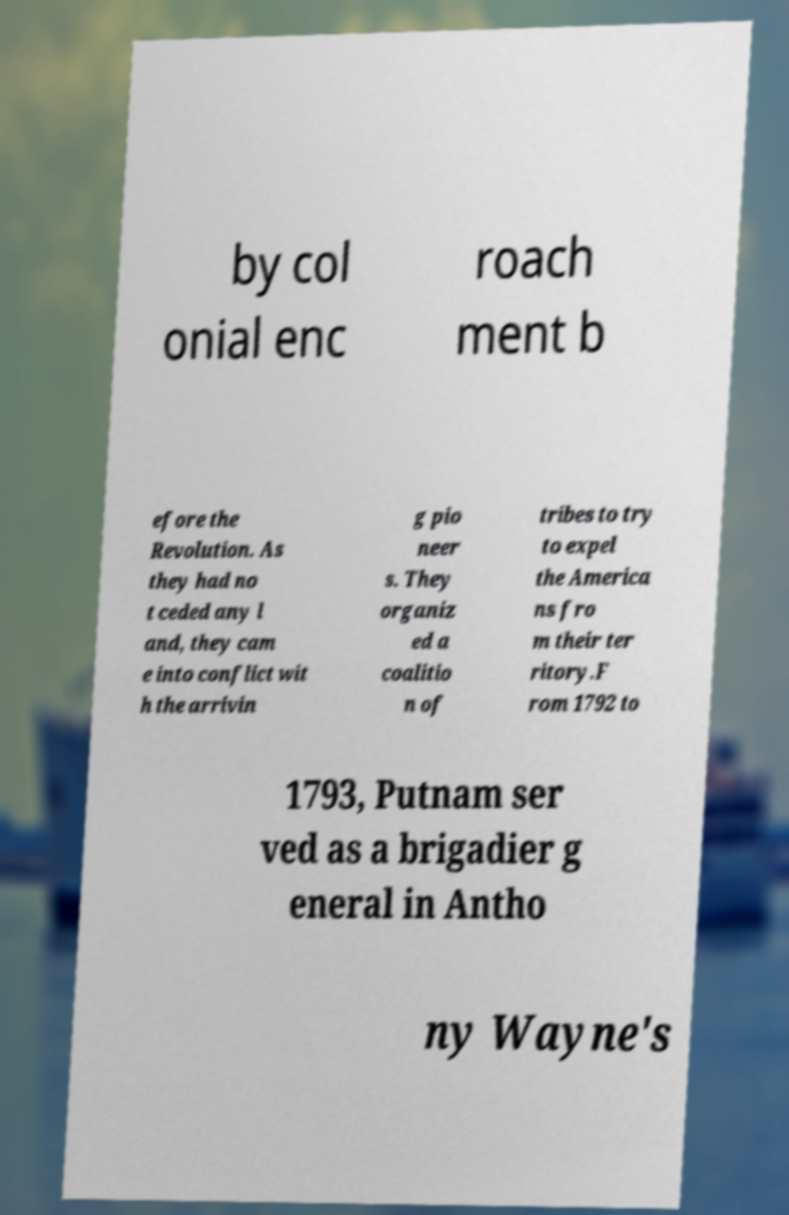Can you accurately transcribe the text from the provided image for me? by col onial enc roach ment b efore the Revolution. As they had no t ceded any l and, they cam e into conflict wit h the arrivin g pio neer s. They organiz ed a coalitio n of tribes to try to expel the America ns fro m their ter ritory.F rom 1792 to 1793, Putnam ser ved as a brigadier g eneral in Antho ny Wayne's 